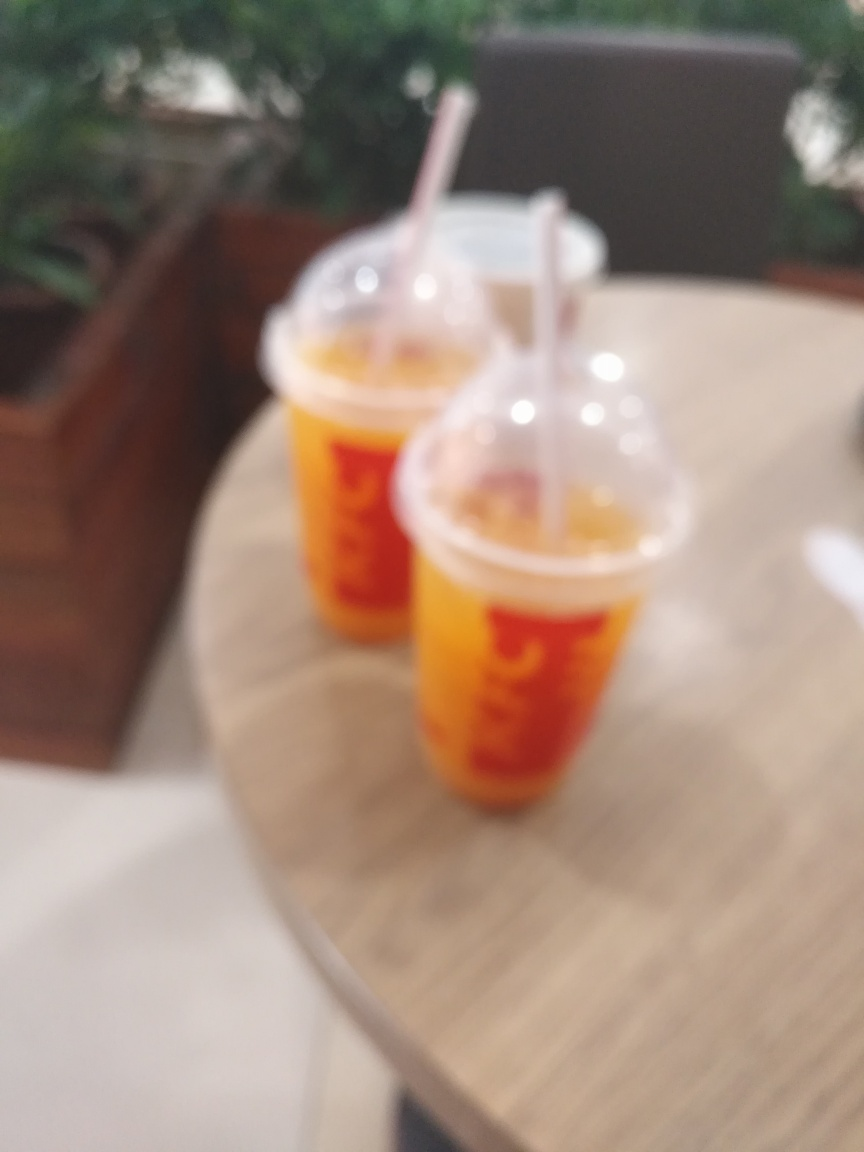How would you describe the composition of this image? Choose the option's letter from the given choices directly. Given that the image is blurry and lacks clear subject focus, the composition of this image would not typically be considered outstanding, excellent, or superior by conventional photography standards. The assessment of 'Poor' aligns with the fact that the main subjects, which appear to be two cups on a table, are not in sharp focus and the setting does not convey a purposeful or aesthetically compelling arrangement. Hence, option 'D' Poor, is the accurate choice for describing the composition. 